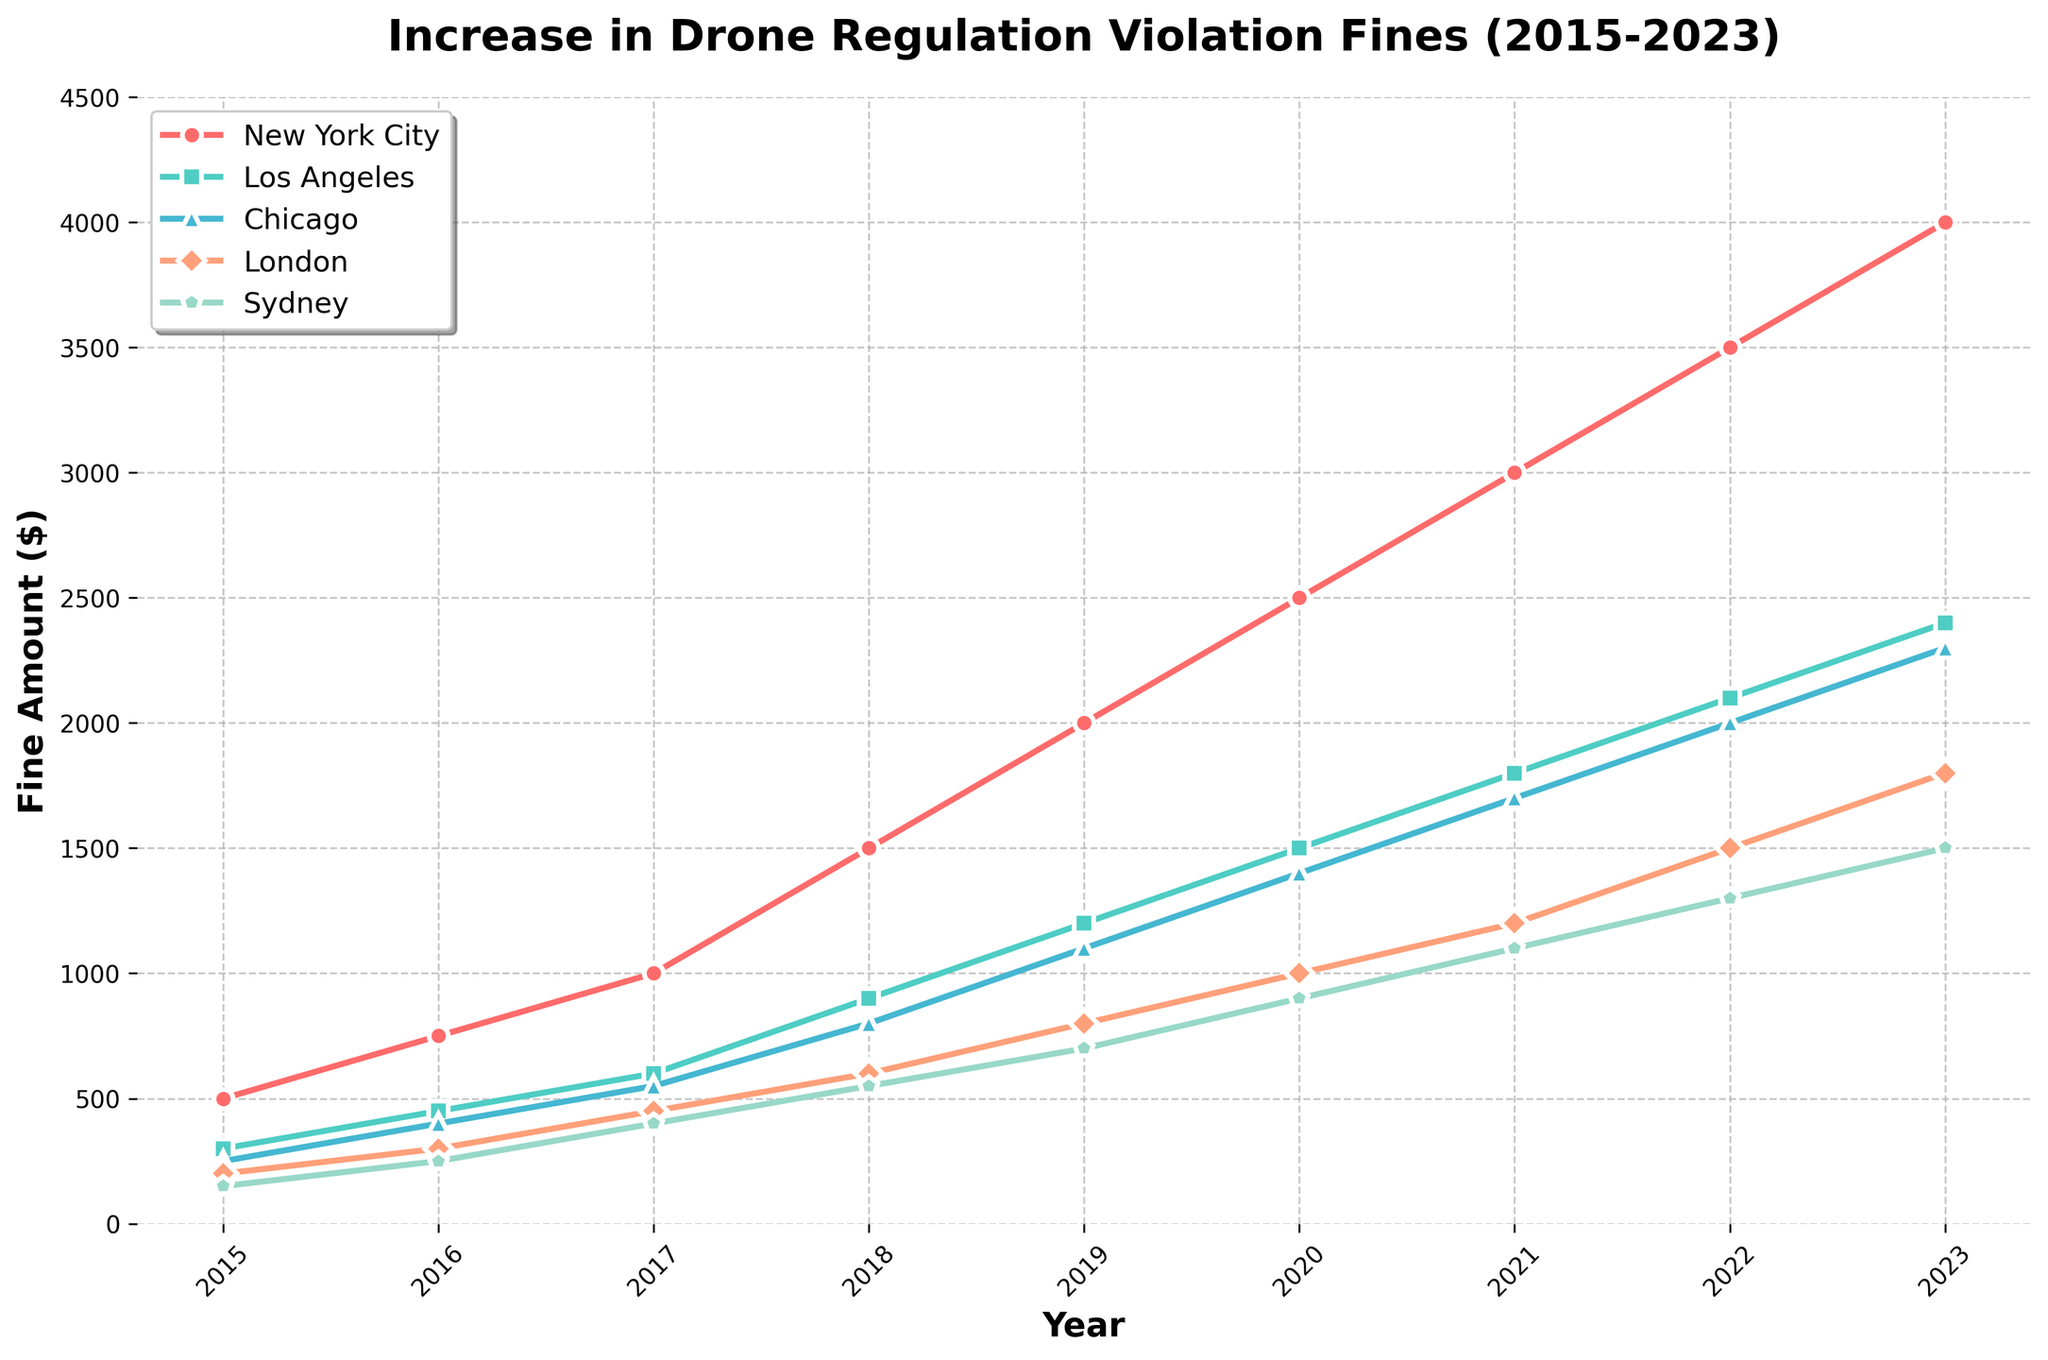How much did the fines for drone regulation violations increase in New York City from 2015 to 2023? To find the increase, subtract the fine in 2015 from the fine in 2023: 4000 - 500 = 3500.
Answer: 3500 Which city had the highest fine for drone regulation violations in 2023? Observing the chart, New York City had the highest fine amount in 2023 at $4000.
Answer: New York City What was the difference in the fine amount between Los Angeles and Chicago in 2019? In 2019, Los Angeles had fines of $1200 and Chicago had fines of $1100. The difference is 1200 - 1100 = 100.
Answer: 100 Among the five cities, which one showed the most significant increase in fine amount from 2015 to 2023? By visually comparing the increasing trend from the plot, New York City shows the steepest rise from $500 to $4000, which is a $3500 increase, the maximum among all.
Answer: New York City What is the average fine amount for London from 2018 to 2020? The fines for London in the given years are $600 (2018), $800 (2019), and $1000 (2020). Average = (600 + 800 + 1000) / 3 = 2400 / 3 = 800.
Answer: 800 In which year did Sydney experience its first dramatic increase in fines? By examining the plot for Sydney, the first major increase appears between 2016 ($250) and 2017 ($400).
Answer: 2017 How much did the fines for drone violations increase in Los Angeles from 2021 to 2023? First, find the difference in the fine amounts between 2021 ($1800) and 2023 ($2400): 2400 - 1800 = 600.
Answer: 600 Which city had the smallest fine increase from 2022 to 2023? By examining the chart, all cities are compared between 2022 and 2023. Sydney shows the smallest increase (1500-1300 = 200).
Answer: Sydney Which year's fines in Chicago matched the fines in Los Angeles in 2017? Compare fines for different years. Chicago's fine in 2020 ($1400) matches Los Angeles' fine in 2017.
Answer: 2020 What visual attribute differentiates the fine trend for New York City and Sydney? Observing the line colors, New York City's line is red, and Sydney's is a purplish color. Moreover, New York City's line is significantly steeper compared to Sydney.
Answer: Color and gradient 